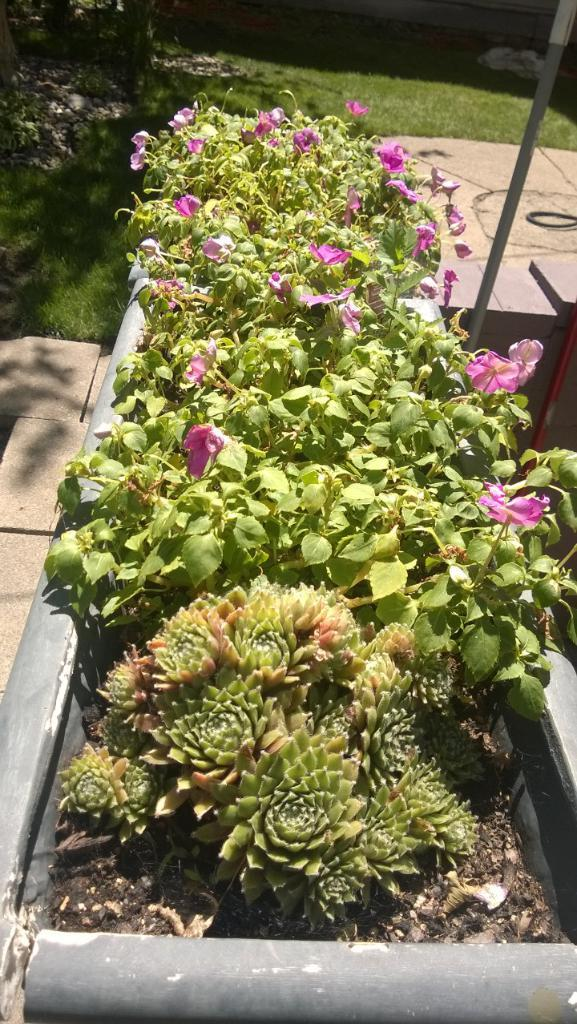What is the main subject in the center of the image? There are plants in a flower pot in the center of the image. What type of vegetation can be seen in the background of the image? There is grass visible in the background of the image. What object is located to the right side of the image? There is a pole to the right side of the image. Can you tell me who is arguing with the spy in the image? There is no argument or spy present in the image; it features plants in a flower pot, grass in the background, and a pole to the right side. 